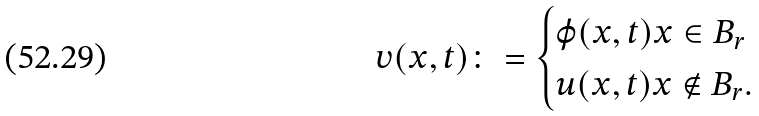Convert formula to latex. <formula><loc_0><loc_0><loc_500><loc_500>v ( x , t ) \colon = \begin{cases} \varphi ( x , t ) x \in B _ { r } \\ u ( x , t ) x \notin B _ { r } . \end{cases}</formula> 